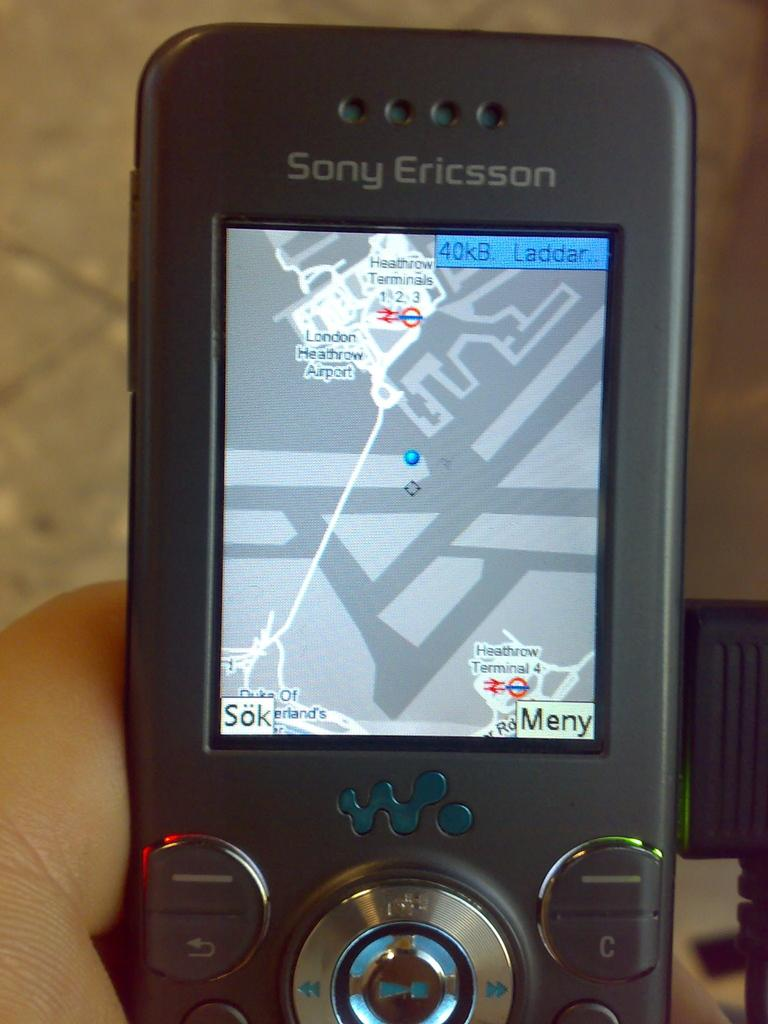What can be seen in the person's hand in the image? The hand is holding a mobile device. What is the mobile device displaying? The mobile device's display shows navigation. How would you describe the background of the image? The background of the image is blurred. Is there any gold visible in the image? There is no gold present in the image. Can you see any ghosts in the background of the image? There are no ghosts present in the image; the background is blurred but does not show any ghosts. 